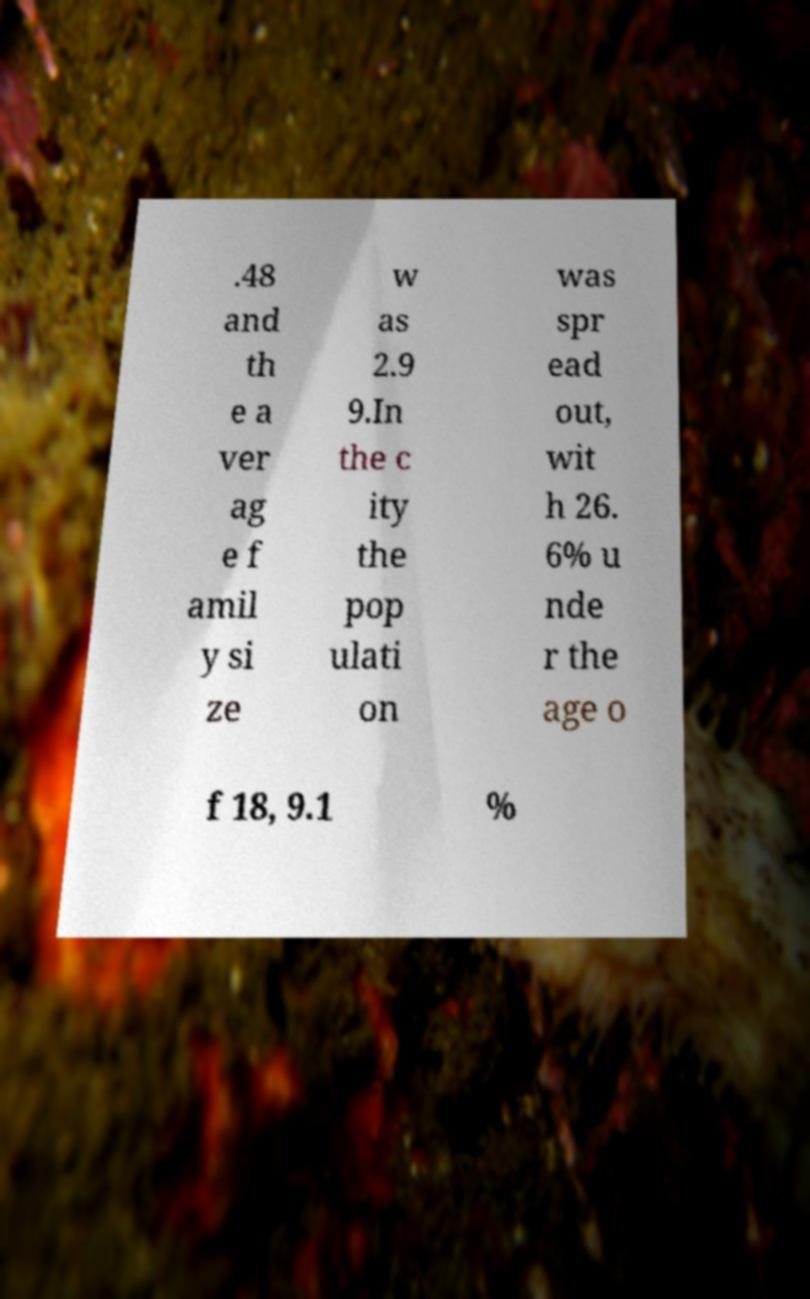Can you read and provide the text displayed in the image?This photo seems to have some interesting text. Can you extract and type it out for me? .48 and th e a ver ag e f amil y si ze w as 2.9 9.In the c ity the pop ulati on was spr ead out, wit h 26. 6% u nde r the age o f 18, 9.1 % 